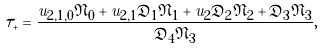Convert formula to latex. <formula><loc_0><loc_0><loc_500><loc_500>\tau _ { + } = \frac { u _ { 2 , 1 , 0 } \mathfrak { N } _ { 0 } + u _ { 2 , 1 } \mathfrak { D } _ { 1 } \mathfrak { N } _ { 1 } + u _ { 2 } \mathfrak { D } _ { 2 } \mathfrak { N } _ { 2 } + \mathfrak { D } _ { 3 } \mathfrak { N } _ { 3 } } { \mathfrak { D } _ { 4 } \mathfrak { N } _ { 3 } } ,</formula> 